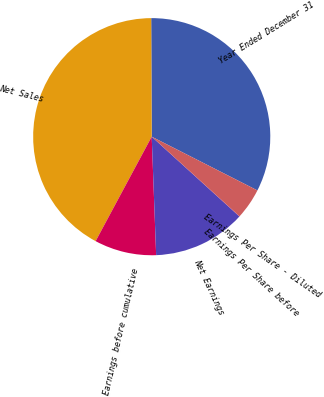<chart> <loc_0><loc_0><loc_500><loc_500><pie_chart><fcel>Year Ended December 31<fcel>Net Sales<fcel>Earnings before cumulative<fcel>Net Earnings<fcel>Earnings Per Share before<fcel>Earnings Per Share - Diluted<nl><fcel>32.56%<fcel>42.09%<fcel>8.44%<fcel>12.65%<fcel>0.03%<fcel>4.24%<nl></chart> 